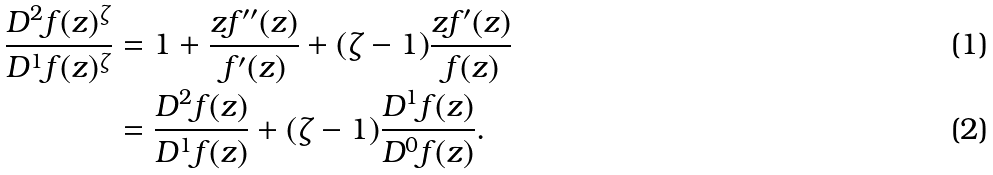<formula> <loc_0><loc_0><loc_500><loc_500>\frac { D ^ { 2 } f ( z ) ^ { \zeta } } { D ^ { 1 } f ( z ) ^ { \zeta } } & = 1 + \frac { z f ^ { \prime \prime } ( z ) } { f ^ { \prime } ( z ) } + ( \zeta - 1 ) \frac { z f ^ { \prime } ( z ) } { f ( z ) } \\ & = \frac { D ^ { 2 } f ( z ) } { D ^ { 1 } f ( z ) } + ( \zeta - 1 ) \frac { D ^ { 1 } f ( z ) } { D ^ { 0 } f ( z ) } .</formula> 